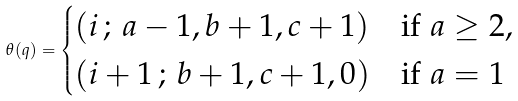<formula> <loc_0><loc_0><loc_500><loc_500>\theta ( q ) = \begin{cases} ( i \, ; \, a - 1 , b + 1 , c + 1 ) & \text {if $a\geq 2$,} \\ ( i + 1 \, ; \, b + 1 , c + 1 , 0 ) & \text {if $a = 1$} \end{cases}</formula> 